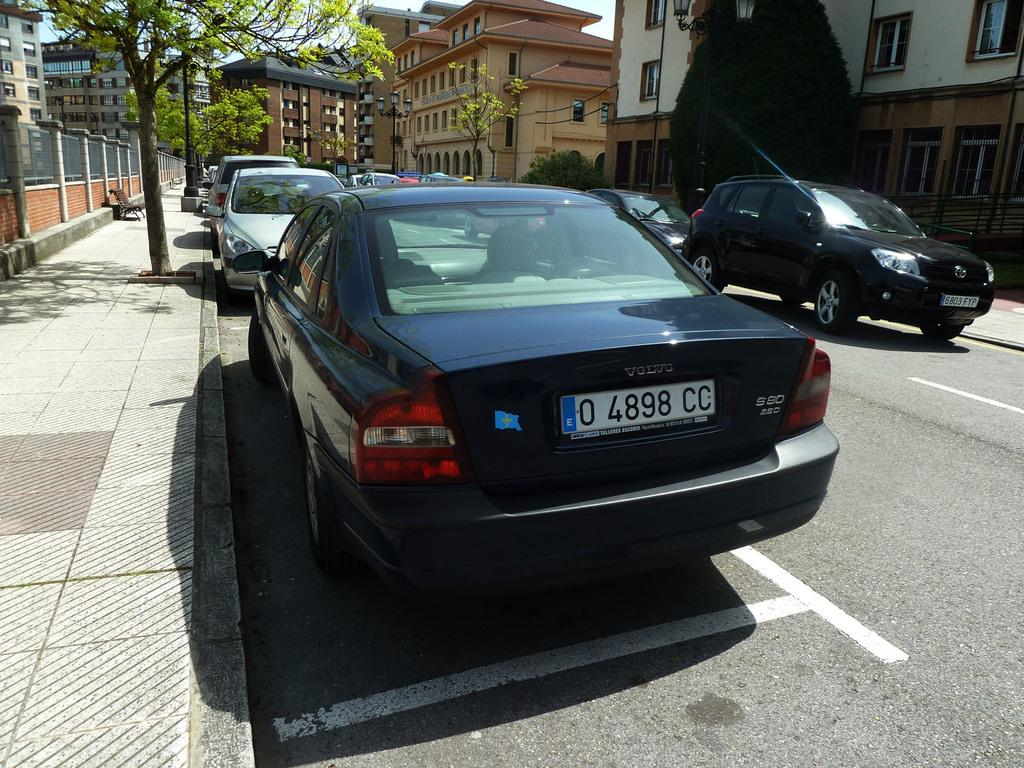<image>
Give a short and clear explanation of the subsequent image. A dark colored Volvo with license plate 0 4898 is parked next to the sidewalk. 